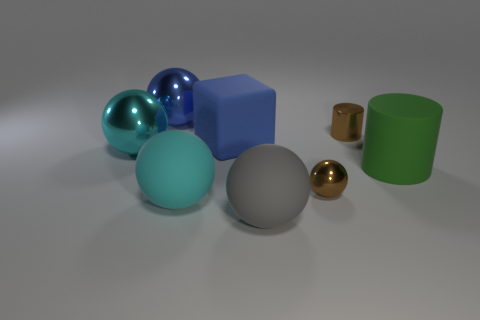If I were to arrange these objects by size, which would come first and which would come last? To arrange these objects by size, starting with the smallest, you would begin with the tiny gold-colored sphere on the left side of the tiny brown cylinder. The largest object in the scene is the blue cube placed roughly in the center. So the arrangement from smallest to largest would start with the tiny gold-colored sphere and culminate with the blue cube. 